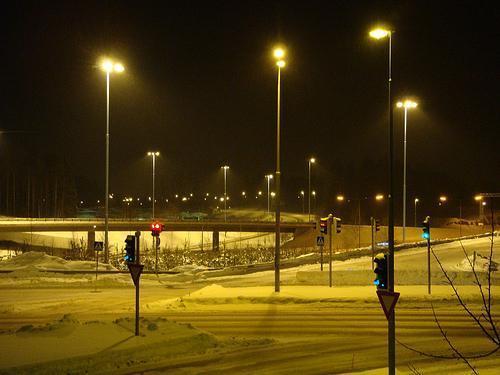How many traffic lights are green in the image?
Give a very brief answer. 3. 